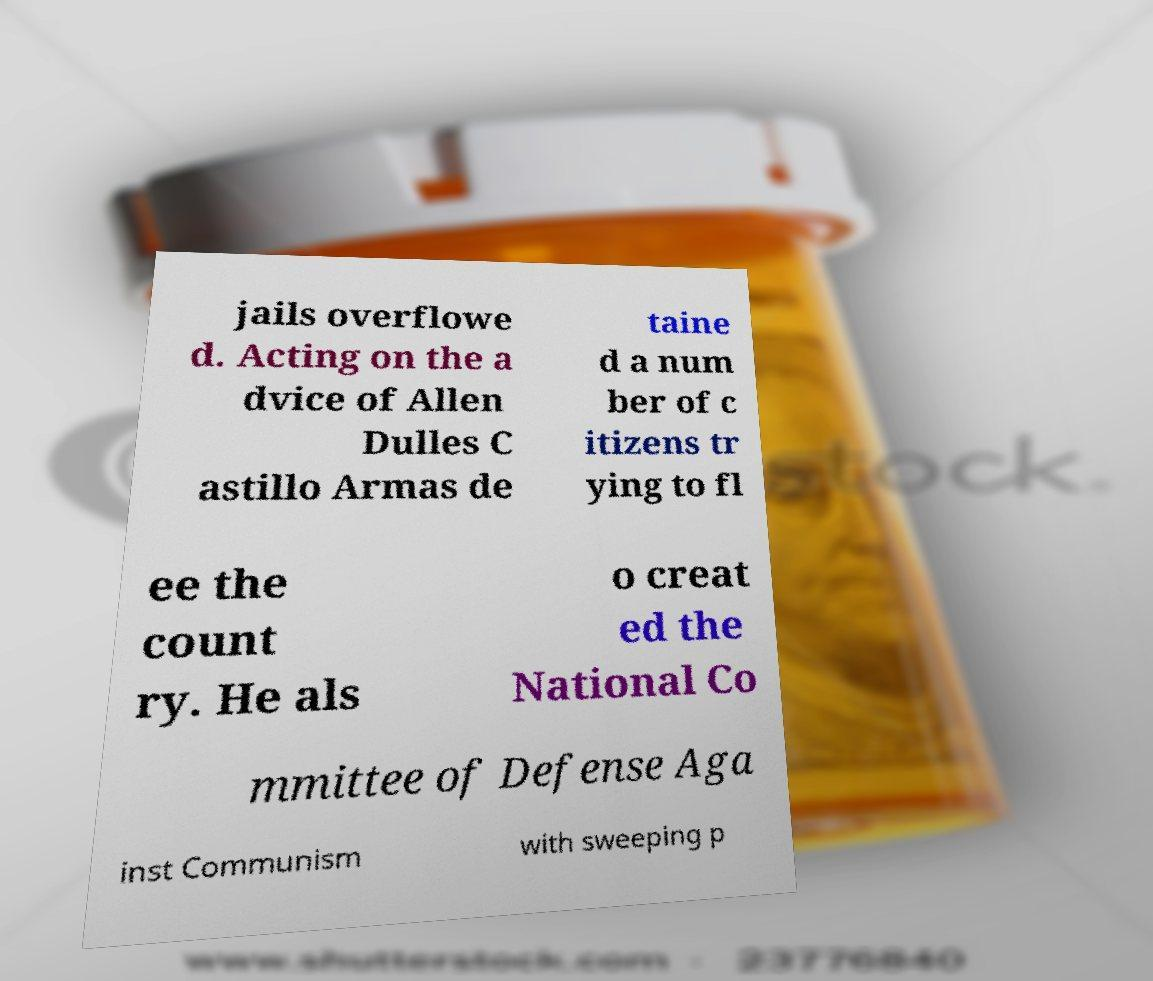Can you read and provide the text displayed in the image?This photo seems to have some interesting text. Can you extract and type it out for me? jails overflowe d. Acting on the a dvice of Allen Dulles C astillo Armas de taine d a num ber of c itizens tr ying to fl ee the count ry. He als o creat ed the National Co mmittee of Defense Aga inst Communism with sweeping p 